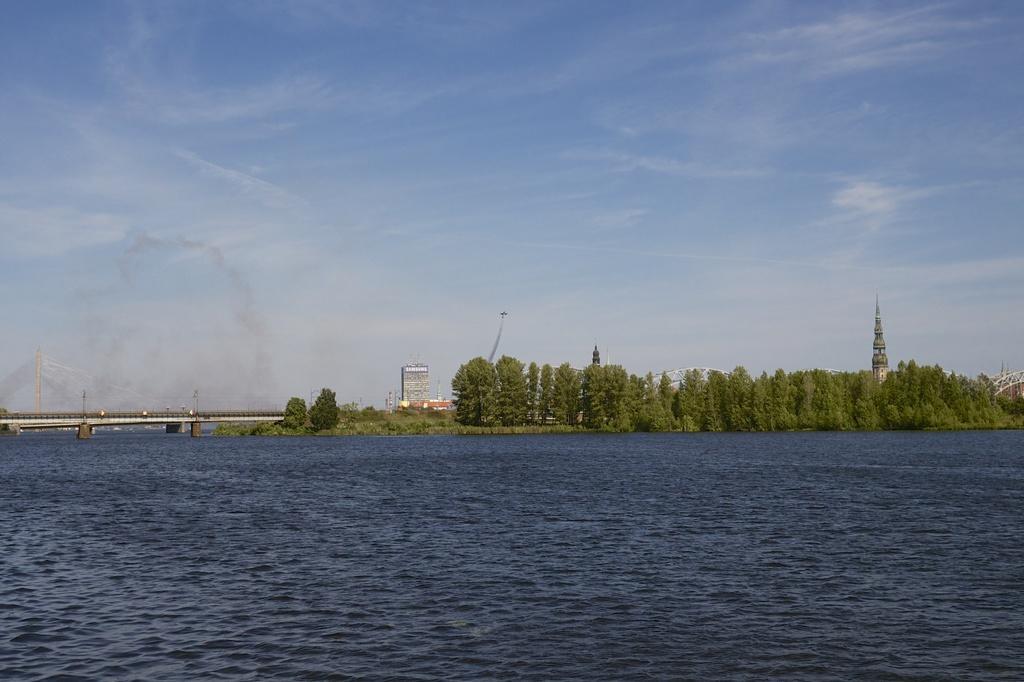Please provide a concise description of this image. This is water. Here we can see trees, bridge, and buildings. In the background there is sky. 